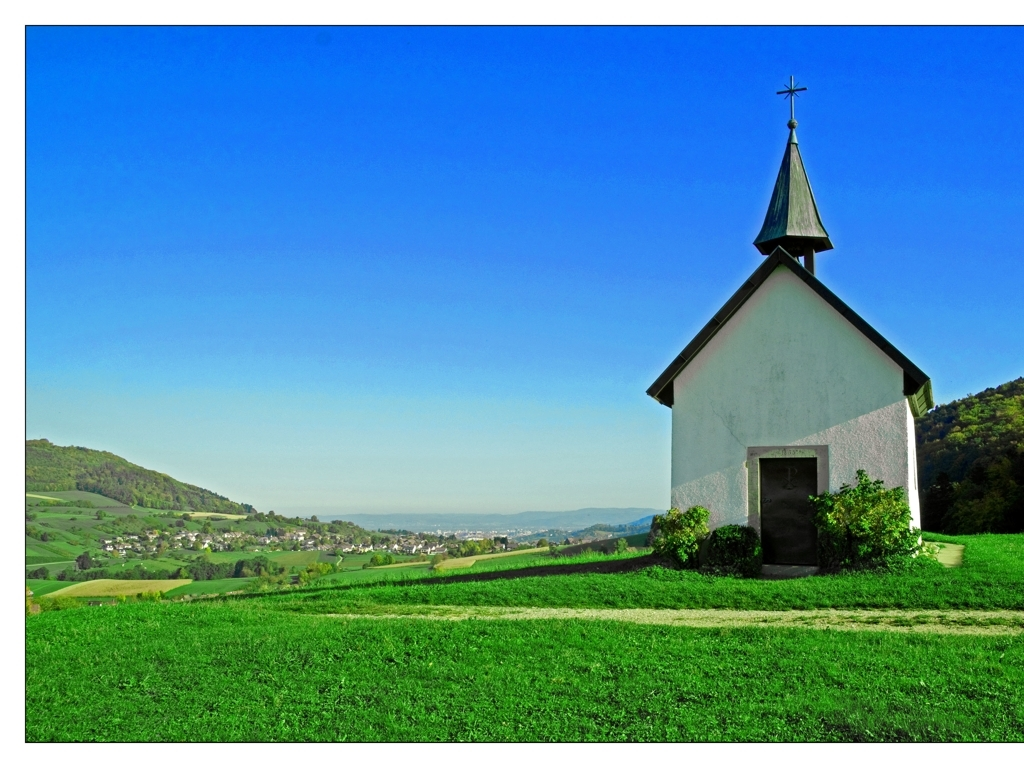What time of day does it appear to be? Given the long shadows on the ground and the quality of light, it seems to be late afternoon when the sun is beginning to lower in the sky, casting a warm, golden hue across the landscape. 